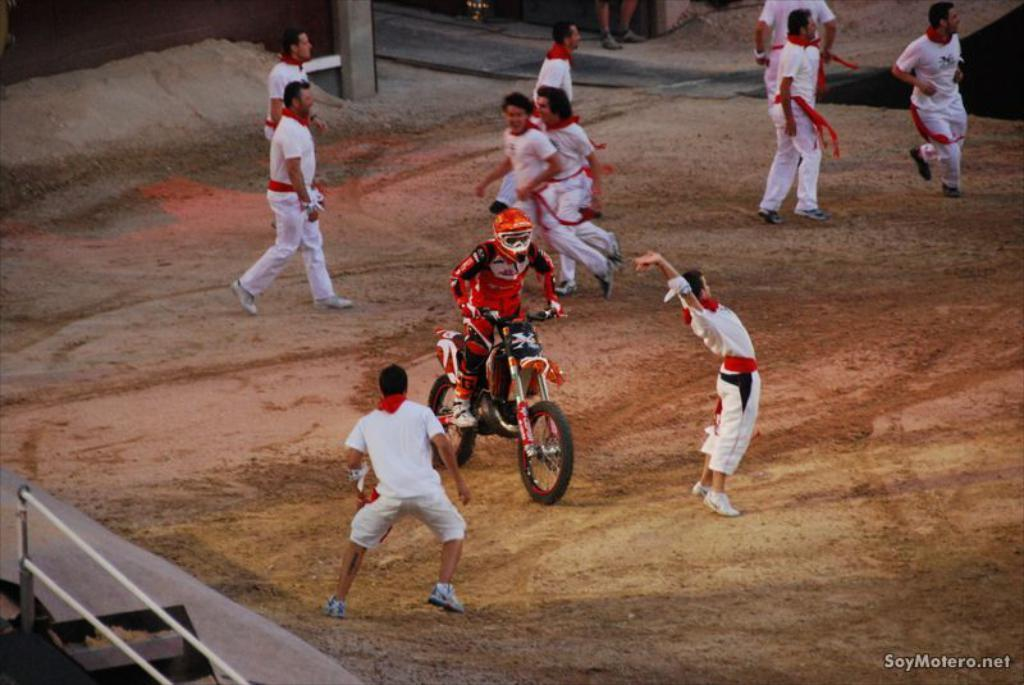What is the main subject of the image? The main subject of the image is a person riding a motorbike. Can you describe the person's attire? The person is wearing a red dress and a helmet. What are the other boys in the image doing? The boys are running on the ground. What color are the boys' dresses? The boys are wearing white dresses. What type of engine is used in the motorbike in the image? The provided facts do not mention the type of engine used in the motorbike, so it cannot be determined from the image. Is there a carpenter present in the image? There is no mention of a carpenter in the provided facts, so it cannot be determined if one is present in the image. 